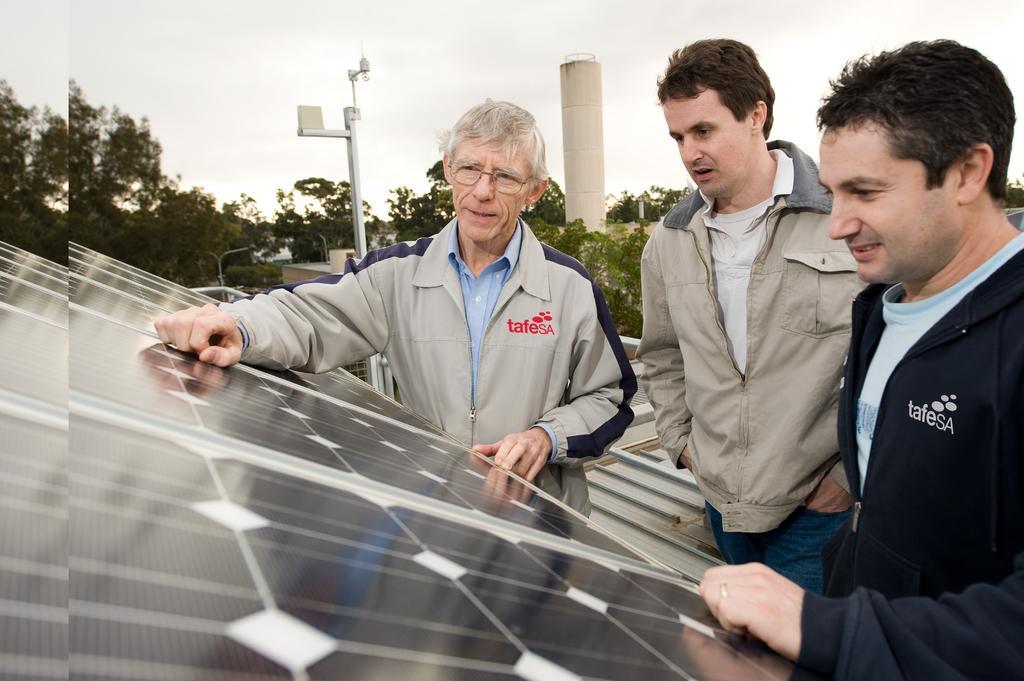Describe this image in one or two sentences. In the image we can see there are men standing and there is a solar panels. There is a street light pole and there is a tower building. Behind there are trees and the sky is clear. 